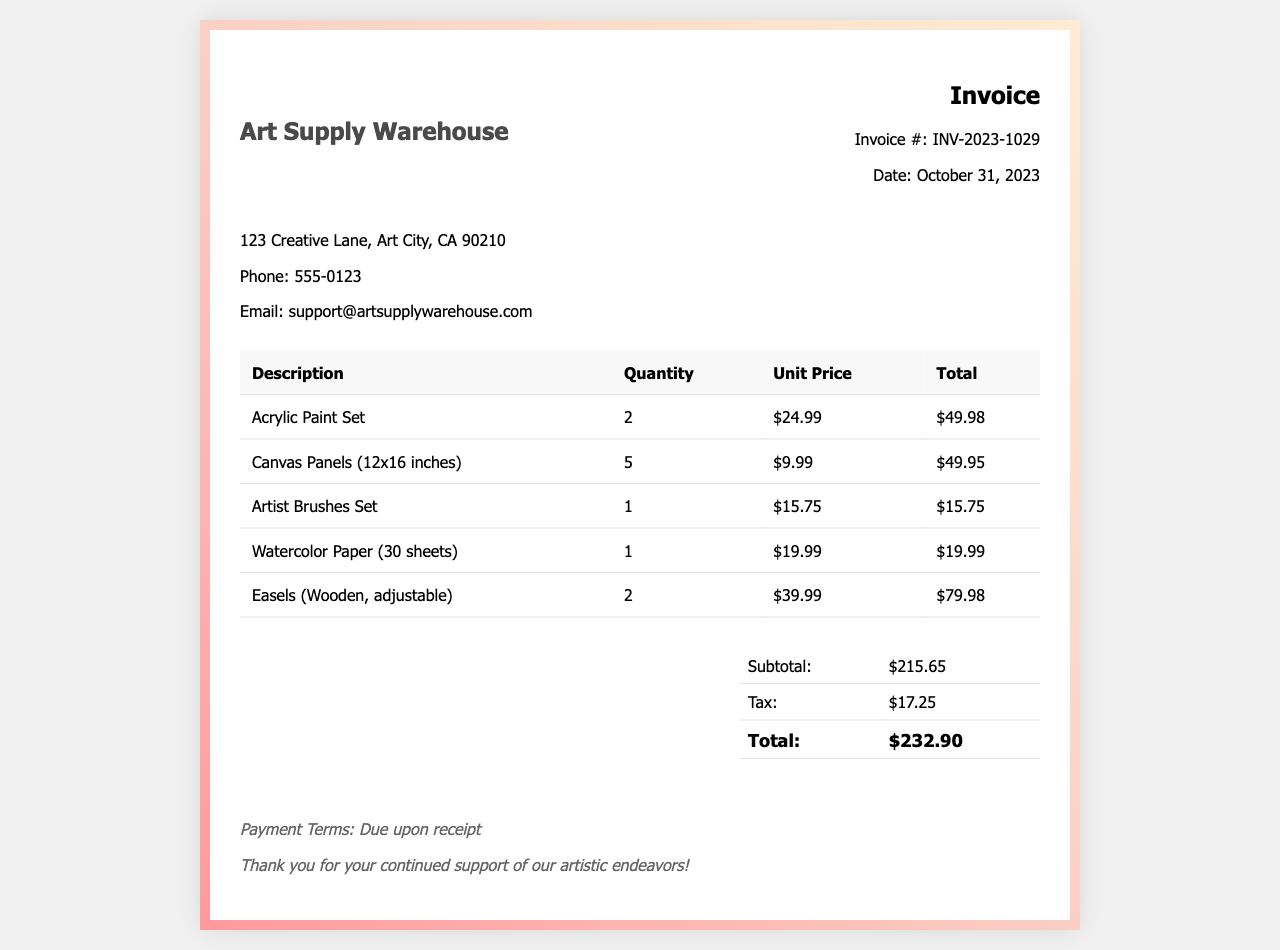What is the invoice number? The invoice number is listed at the top of the document.
Answer: INV-2023-1029 What is the date of the invoice? The date of the invoice is mentioned in the invoice details section.
Answer: October 31, 2023 What is the total amount due? The total amount is calculated in the total section of the invoice.
Answer: $232.90 How many units of Acrylic Paint Set were purchased? The quantity for the Acrylic Paint Set can be found in the itemized list.
Answer: 2 What is the subtotal before tax? The subtotal is shown in the total section, before tax is added.
Answer: $215.65 What is the vendor's phone number? The vendor's contact information includes their phone number.
Answer: 555-0123 What is the itemized cost of Artist Brushes Set? The total cost for the Artist Brushes Set is listed in the table.
Answer: $15.75 How many Canvas Panels were purchased? The quantity of Canvas Panels is mentioned in the itemized section of the invoice.
Answer: 5 What is the payment term specified in the invoice? The payment term can be found in the notes section of the document.
Answer: Due upon receipt 